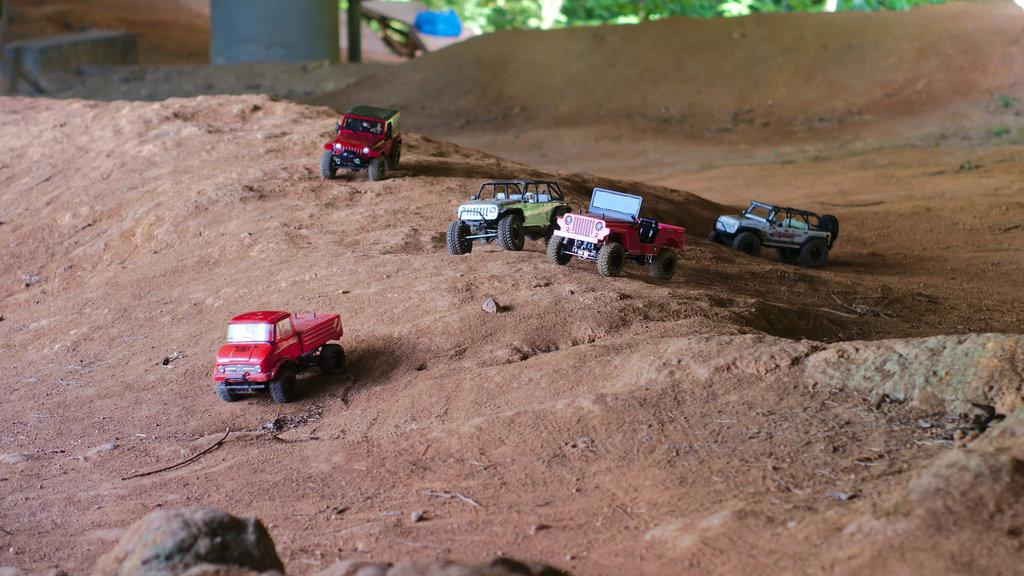What types of objects are on the ground in the image? There are vehicles and other unspecified objects on the ground in the image. What else can be seen in the image besides the objects on the ground? There are trees and a pole in the image. How many rabbits can be seen on the calendar in the image? There is no calendar or rabbits present in the image. What is the limit of objects that can be placed on the ground in the image? There is no limit mentioned for the number of objects that can be placed on the ground in the image. 